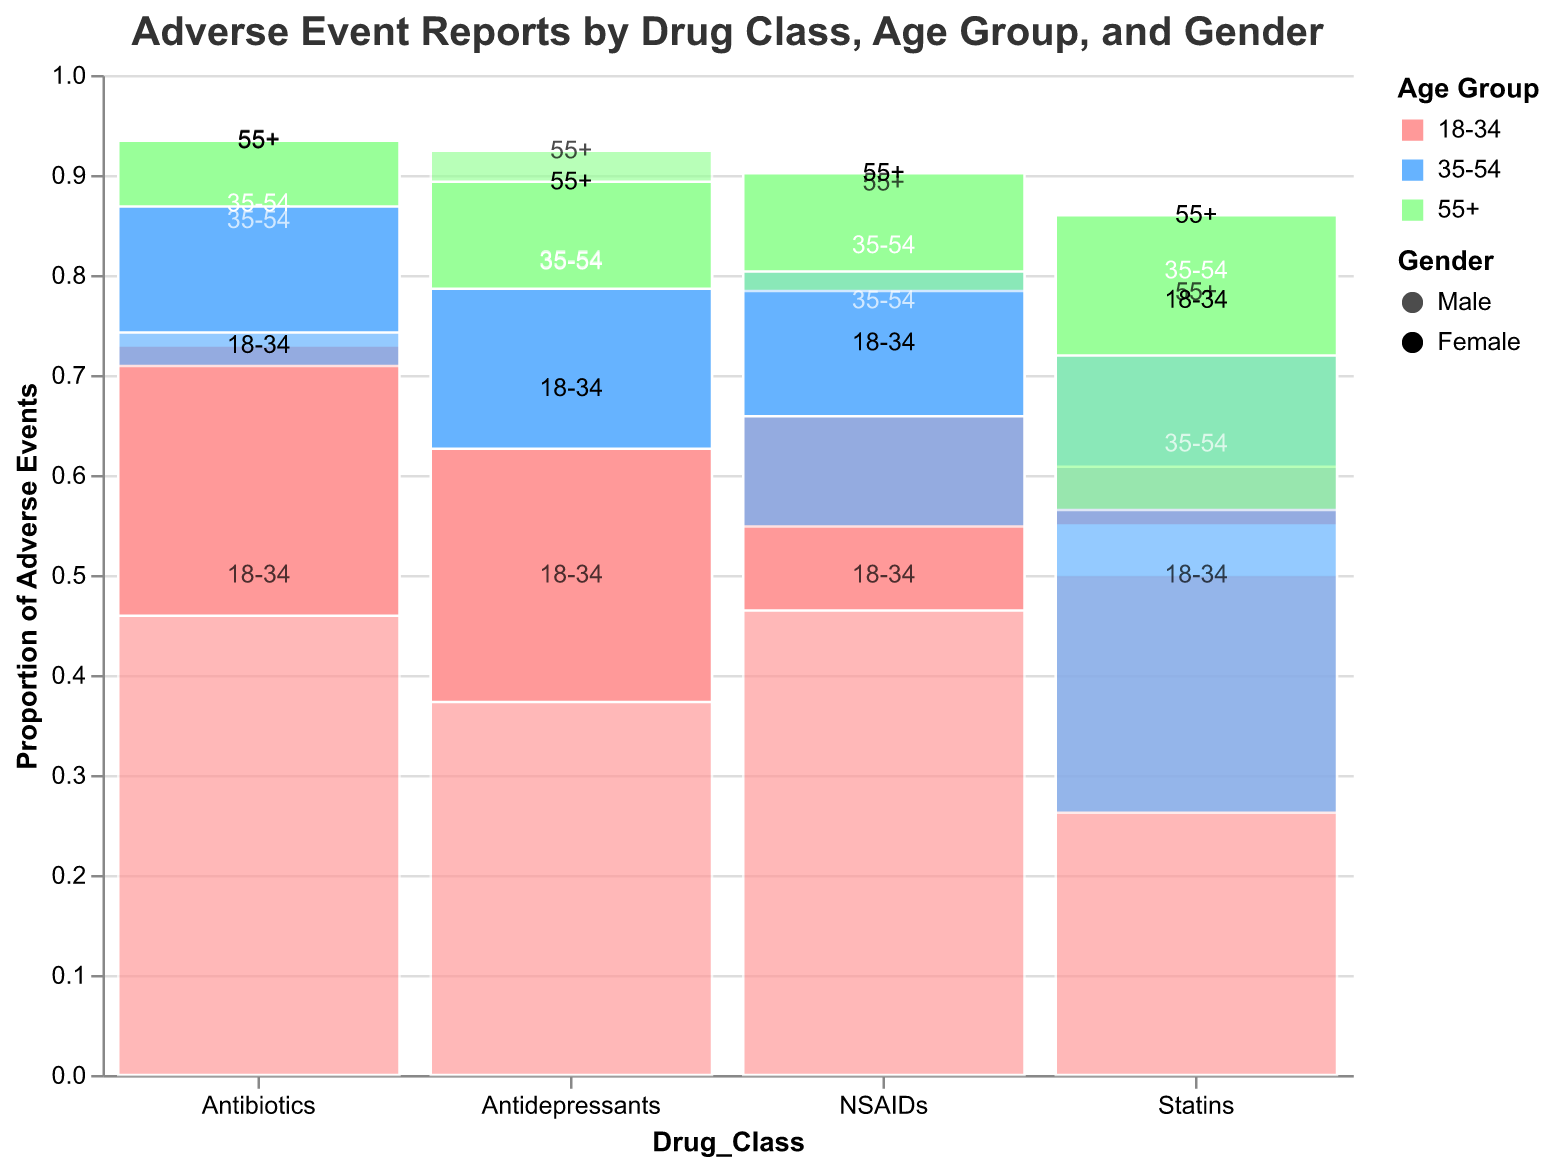What is the total number of adverse events reported for Statins in the age group 55+? First, locate the data for Statins and find the segment for the age group "55+". Sum the counts for both male (782) and female (701) in this age group. The total is 782 + 701 = 1,483.
Answer: 1,483 Which age group has the highest number of adverse events reported for Antidepressants? Look at the segments for Antidepressants and compare the counts for each age group. The 35-54 age group has the highest counts with 387 (Male) + 623 (Female) = 1,010.
Answer: 35-54 Compare the adverse events reported for NSAIDs in the age groups 35-54 and 55+. Which age group has fewer events? Sum the counts for both genders in the given age groups. For 35-54, it's 312 (Male) + 358 (Female) = 670. For 55+, it's 289 (Male) + 327 (Female) = 616. The 55+ age group has fewer events.
Answer: 55+ What proportion of adverse events for Antibiotics are reported by females in the 18-34 age group? Find the count for females in the 18-34 age group (378) and the total for all genders and age groups for Antibiotics. First, sum all counts for Antibiotics (321+378+287+342+198+231 = 1,757). Then, calculate the proportion: 378 / 1,757 ≈ 0.215.
Answer: 0.215 Between males and females, which gender reports more adverse events for all drug classes combined? Sum the counts of adverse events reported by males and females for all drug classes. For males, sum 245 + 387 + 298 + 89 + 456 + 782 + 321 + 287 + 198 + 176 + 312 + 289 = 3,540. For females, sum 412 + 623 + 534 + 73 + 398 + 701 + 378 + 342 + 231 + 203 + 358 + 327 = 4,580. Females report more adverse events.
Answer: Females What is the summed total of adverse events reported across all drug classes and demographics? Add up all adverse event counts provided in the data. This includes all combinations of Drug_Class, Age_Group, and Gender. The total is 245 + 412 + 387 + 623 + 298 + 534 + 89 + 73 + 456 + 398 + 782 + 701 + 321 + 378 + 287 + 342 + 198 + 231 + 176 + 203 + 312 + 358 + 289 + 327 = 8,120.
Answer: 8,120 Which drug class has the highest total number of adverse events reported? Sum the adverse events for each drug class. Antidepressants: 2,499, Statins: 2,499, Antibiotics: 1,757, NSAIDs: 1,365. Statins and Antidepressants have the highest total, both with 2,499.
Answer: Antidepressants and Statins 